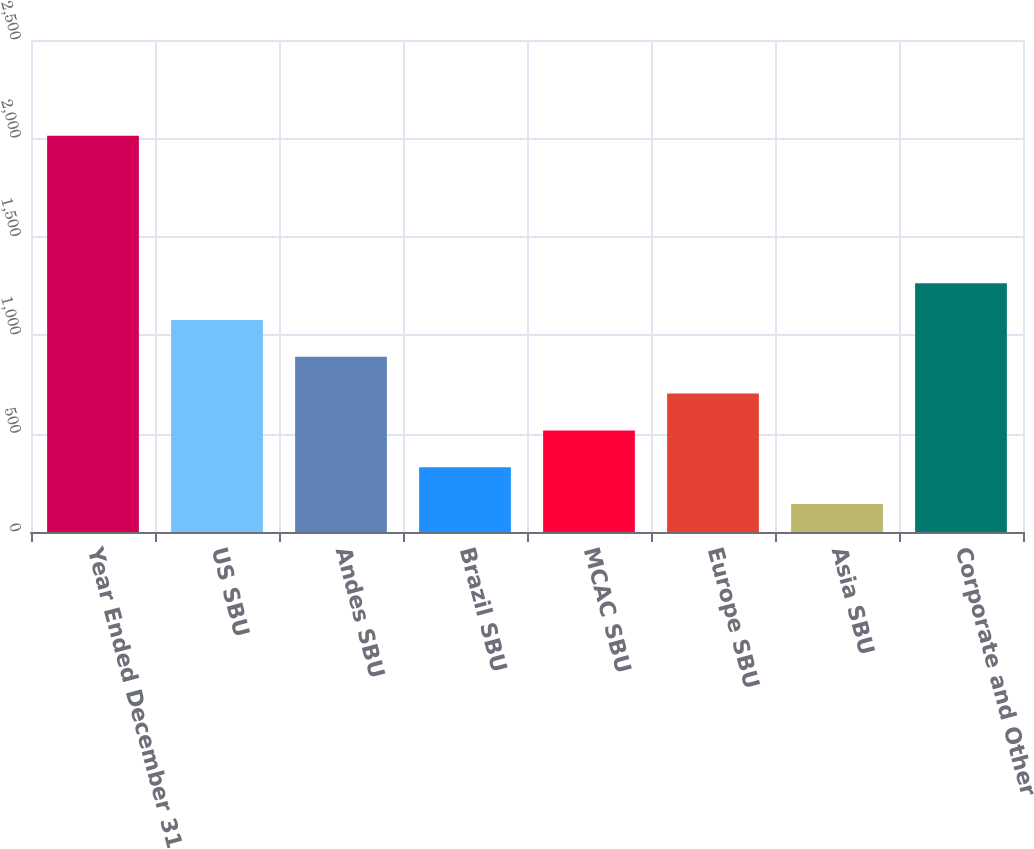<chart> <loc_0><loc_0><loc_500><loc_500><bar_chart><fcel>Year Ended December 31<fcel>US SBU<fcel>Andes SBU<fcel>Brazil SBU<fcel>MCAC SBU<fcel>Europe SBU<fcel>Asia SBU<fcel>Corporate and Other<nl><fcel>2013<fcel>1077.5<fcel>890.4<fcel>329.1<fcel>516.2<fcel>703.3<fcel>142<fcel>1264.6<nl></chart> 